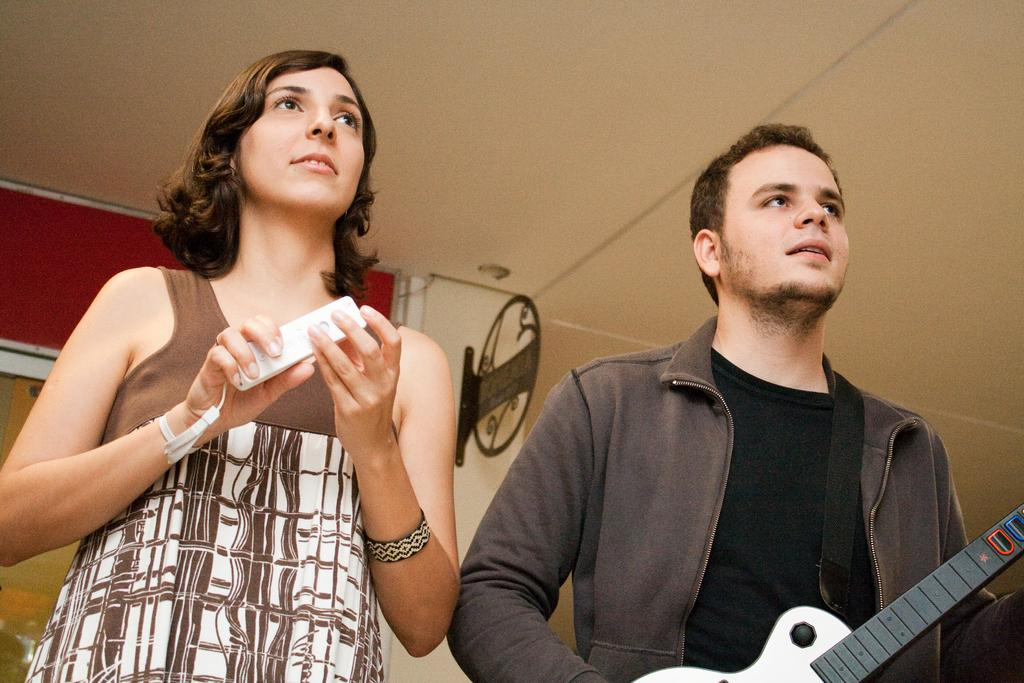What is the man in the image doing? The man is holding a guitar in the image. What is the man wearing? The man is wearing a jacket in the image. What is the woman in the image doing? The woman is holding a phone in the image. What is the expression on the woman's face? The woman is smiling in the image. What can be seen in the background of the image? There is a wall in the background of the image. What type of pies can be seen on the wall in the image? There are no pies present in the image; the background only features a wall. 